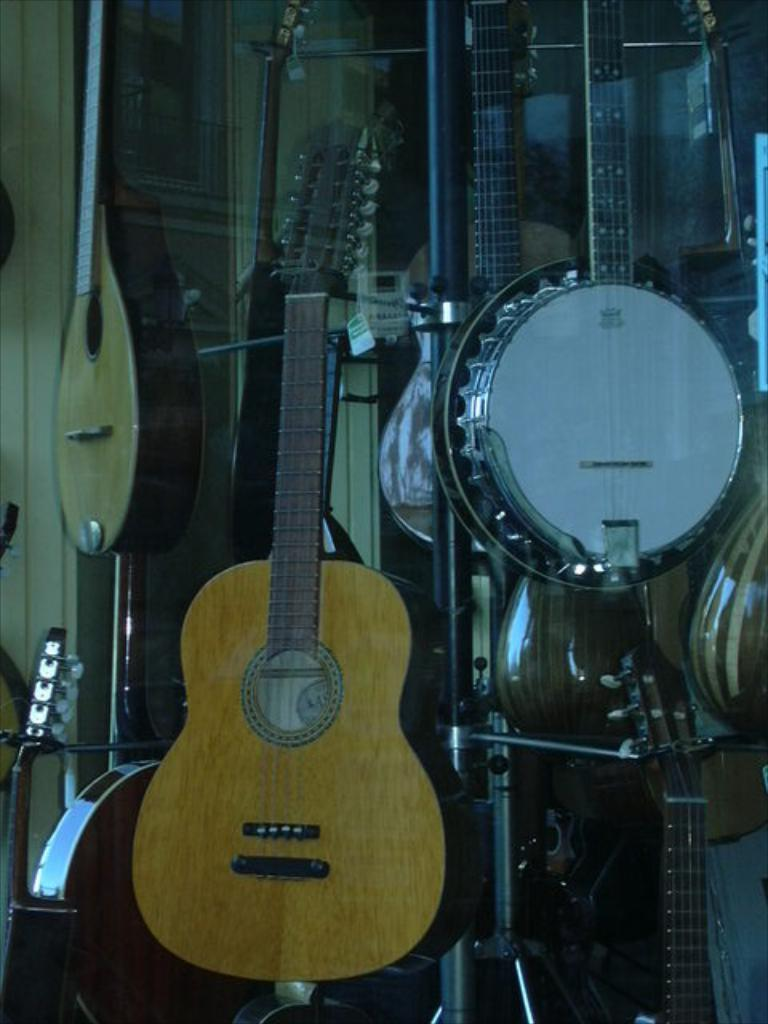What type of musical instrument can be seen in the image? There is a guitar and a violin in the image. Are there any other musical instruments present in the image? Yes, there are other musical instruments in the image. What type of dress is the father wearing in the image? There is no father or dress present in the image; it features musical instruments. 